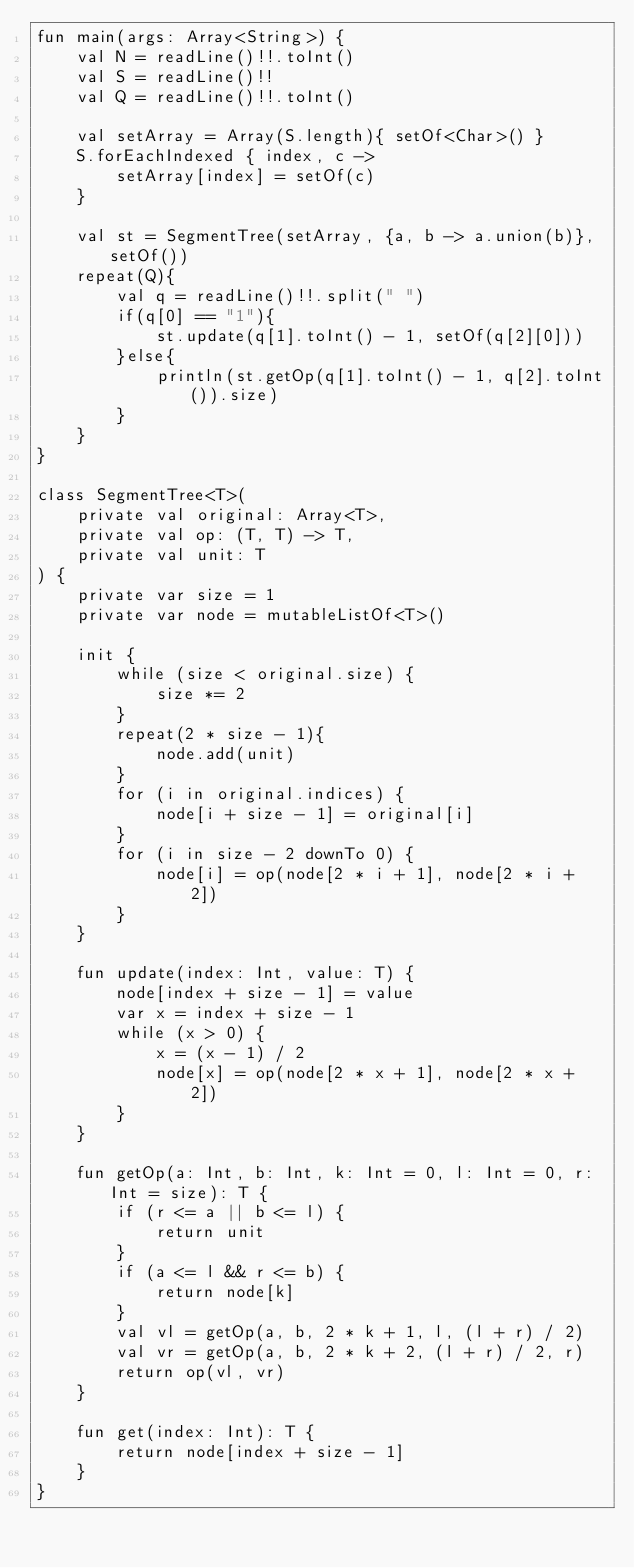<code> <loc_0><loc_0><loc_500><loc_500><_Kotlin_>fun main(args: Array<String>) {
    val N = readLine()!!.toInt()
    val S = readLine()!!
    val Q = readLine()!!.toInt()

    val setArray = Array(S.length){ setOf<Char>() }
    S.forEachIndexed { index, c ->
        setArray[index] = setOf(c)
    }

    val st = SegmentTree(setArray, {a, b -> a.union(b)}, setOf())
    repeat(Q){
        val q = readLine()!!.split(" ")
        if(q[0] == "1"){
            st.update(q[1].toInt() - 1, setOf(q[2][0]))
        }else{
            println(st.getOp(q[1].toInt() - 1, q[2].toInt()).size)
        }
    }
}

class SegmentTree<T>(
    private val original: Array<T>,
    private val op: (T, T) -> T,
    private val unit: T
) {
    private var size = 1
    private var node = mutableListOf<T>()

    init {
        while (size < original.size) {
            size *= 2
        }
        repeat(2 * size - 1){
            node.add(unit)
        }
        for (i in original.indices) {
            node[i + size - 1] = original[i]
        }
        for (i in size - 2 downTo 0) {
            node[i] = op(node[2 * i + 1], node[2 * i + 2])
        }
    }

    fun update(index: Int, value: T) {
        node[index + size - 1] = value
        var x = index + size - 1
        while (x > 0) {
            x = (x - 1) / 2
            node[x] = op(node[2 * x + 1], node[2 * x + 2])
        }
    }

    fun getOp(a: Int, b: Int, k: Int = 0, l: Int = 0, r: Int = size): T {
        if (r <= a || b <= l) {
            return unit
        }
        if (a <= l && r <= b) {
            return node[k]
        }
        val vl = getOp(a, b, 2 * k + 1, l, (l + r) / 2)
        val vr = getOp(a, b, 2 * k + 2, (l + r) / 2, r)
        return op(vl, vr)
    }

    fun get(index: Int): T {
        return node[index + size - 1]
    }
}</code> 